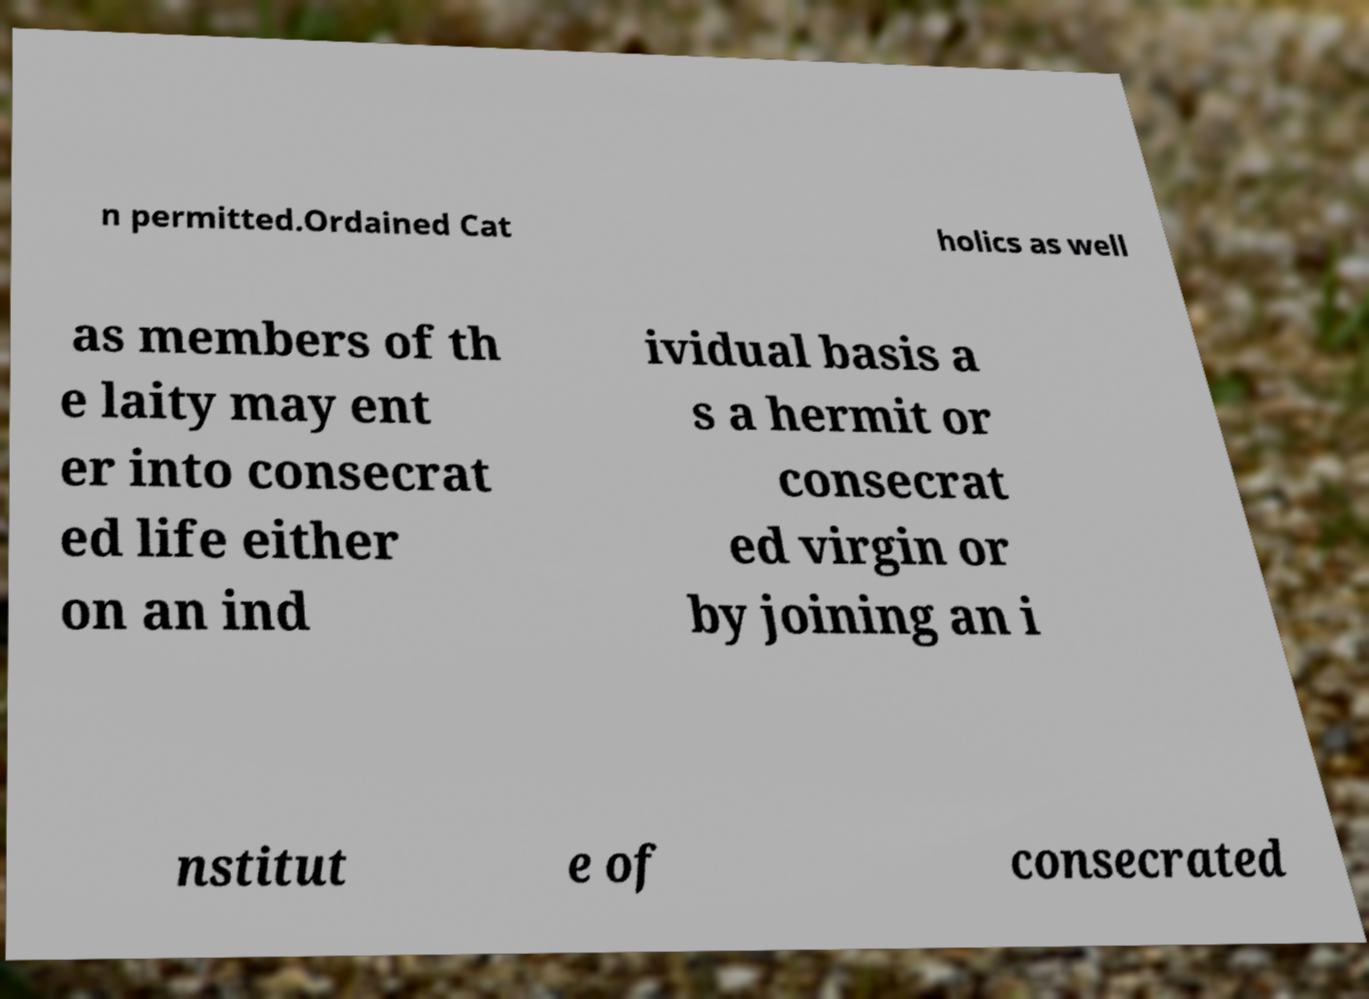Could you extract and type out the text from this image? n permitted.Ordained Cat holics as well as members of th e laity may ent er into consecrat ed life either on an ind ividual basis a s a hermit or consecrat ed virgin or by joining an i nstitut e of consecrated 